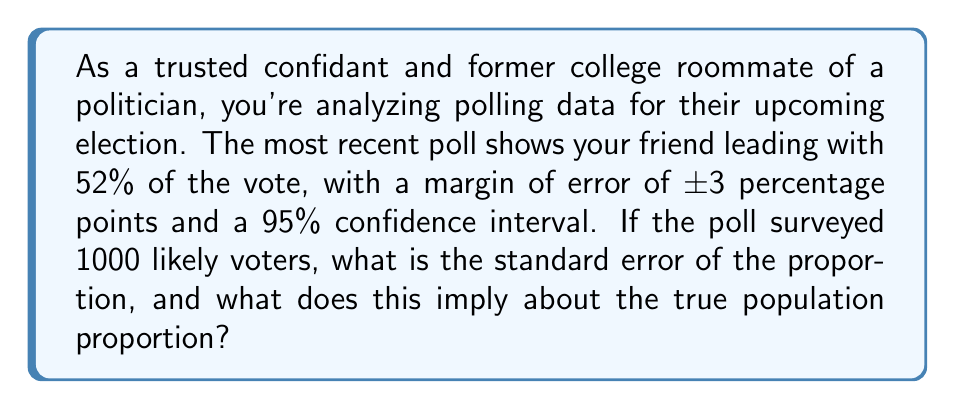Could you help me with this problem? To solve this problem, we'll follow these steps:

1) First, we need to calculate the standard error of the proportion. The formula for standard error (SE) of a proportion is:

   $$ SE = \sqrt{\frac{p(1-p)}{n}} $$

   where $p$ is the sample proportion and $n$ is the sample size.

2) We're given that $p = 0.52$ and $n = 1000$. Let's substitute these values:

   $$ SE = \sqrt{\frac{0.52(1-0.52)}{1000}} = \sqrt{\frac{0.2496}{1000}} = \sqrt{0.0002496} \approx 0.0158 $$

3) Now, we know that for a 95% confidence interval, the margin of error is approximately 1.96 times the standard error. We're given that the margin of error is ±3 percentage points, or 0.03. So:

   $$ 0.03 = 1.96 * SE $$

4) We can verify our calculation of SE by dividing both sides by 1.96:

   $$ \frac{0.03}{1.96} \approx 0.0153 $$

   This is very close to our calculated SE of 0.0158, with the small difference due to rounding.

5) To interpret what this means for the true population proportion, we can construct the 95% confidence interval:

   $$ 0.52 \pm (1.96 * 0.0158) = 0.52 \pm 0.031 $$

   So the 95% confidence interval is approximately (0.489, 0.551) or 48.9% to 55.1%.

6) This means we can be 95% confident that the true population proportion falls between 48.9% and 55.1%. While your friend is leading in the poll, the lower bound of the confidence interval is below 50%, indicating that the election could still be competitive.
Answer: The standard error of the proportion is approximately 0.0158 or 1.58%. This implies that we can be 95% confident that the true population proportion falls between 48.9% and 55.1%, suggesting that while your friend is leading in the poll, the election could still be competitive. 